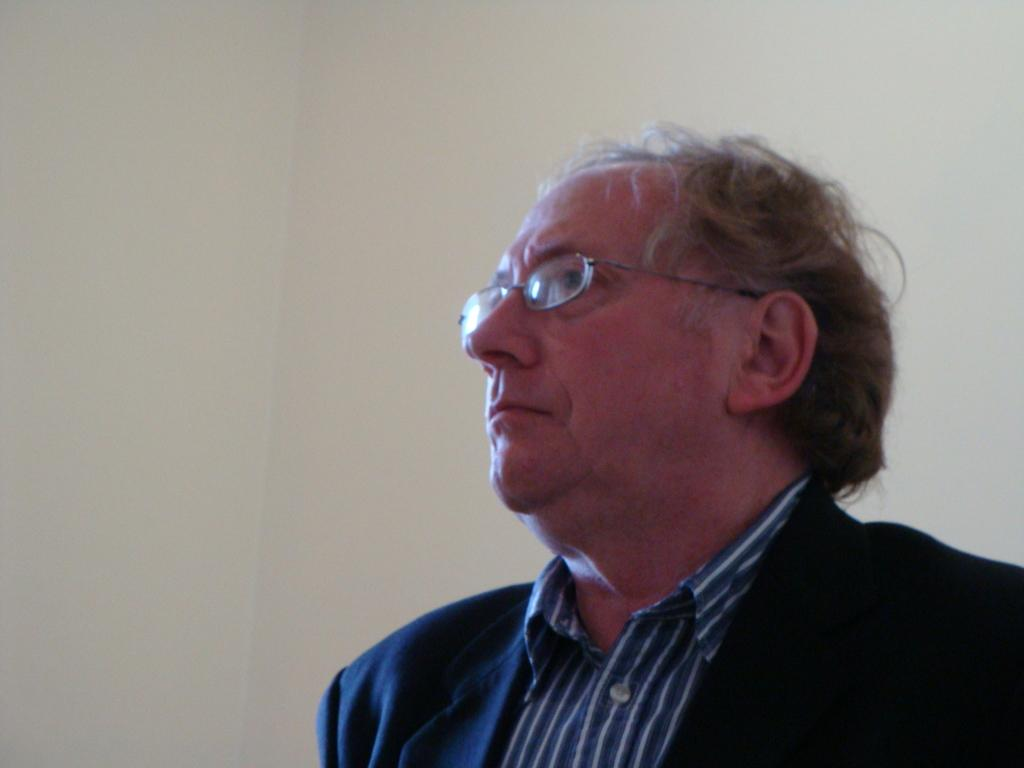Who or what is in the front of the image? There is a person in the front of the image. What can be seen in the background of the image? There is a wall in the background of the image. How many flowers are on the shelf in the image? There are no flowers or shelves present in the image. 